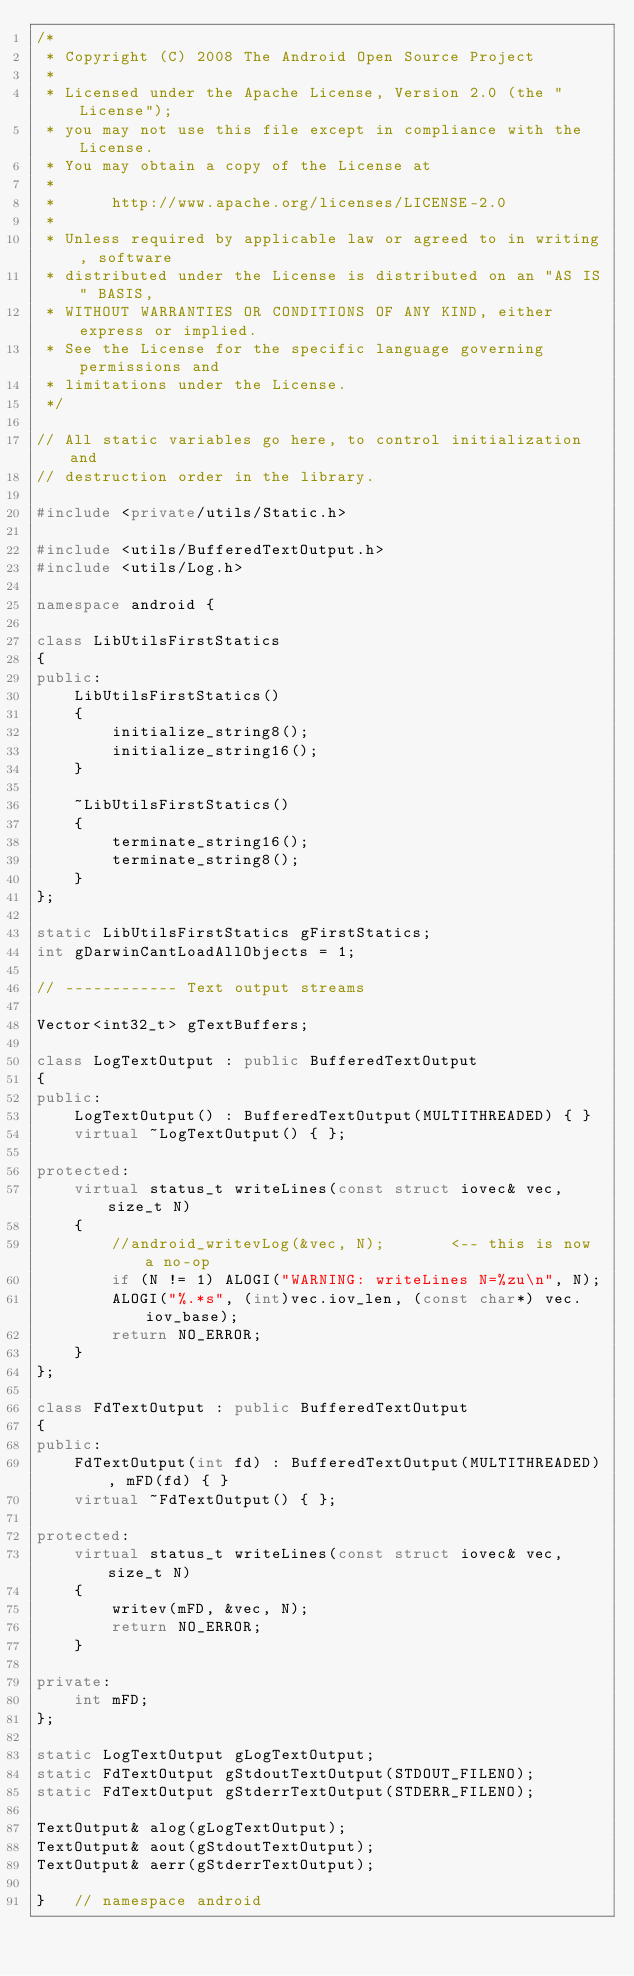Convert code to text. <code><loc_0><loc_0><loc_500><loc_500><_C++_>/*
 * Copyright (C) 2008 The Android Open Source Project
 *
 * Licensed under the Apache License, Version 2.0 (the "License");
 * you may not use this file except in compliance with the License.
 * You may obtain a copy of the License at
 *
 *      http://www.apache.org/licenses/LICENSE-2.0
 *
 * Unless required by applicable law or agreed to in writing, software
 * distributed under the License is distributed on an "AS IS" BASIS,
 * WITHOUT WARRANTIES OR CONDITIONS OF ANY KIND, either express or implied.
 * See the License for the specific language governing permissions and
 * limitations under the License.
 */

// All static variables go here, to control initialization and
// destruction order in the library.

#include <private/utils/Static.h>

#include <utils/BufferedTextOutput.h>
#include <utils/Log.h>

namespace android {

class LibUtilsFirstStatics
{
public:
    LibUtilsFirstStatics()
    {
        initialize_string8();
        initialize_string16();
    }
    
    ~LibUtilsFirstStatics()
    {
        terminate_string16();
        terminate_string8();
    }
};

static LibUtilsFirstStatics gFirstStatics;
int gDarwinCantLoadAllObjects = 1;

// ------------ Text output streams

Vector<int32_t> gTextBuffers;

class LogTextOutput : public BufferedTextOutput
{
public:
    LogTextOutput() : BufferedTextOutput(MULTITHREADED) { }
    virtual ~LogTextOutput() { };

protected:
    virtual status_t writeLines(const struct iovec& vec, size_t N)
    {
        //android_writevLog(&vec, N);       <-- this is now a no-op
        if (N != 1) ALOGI("WARNING: writeLines N=%zu\n", N);
        ALOGI("%.*s", (int)vec.iov_len, (const char*) vec.iov_base);
        return NO_ERROR;
    }
};

class FdTextOutput : public BufferedTextOutput
{
public:
    FdTextOutput(int fd) : BufferedTextOutput(MULTITHREADED), mFD(fd) { }
    virtual ~FdTextOutput() { };

protected:
    virtual status_t writeLines(const struct iovec& vec, size_t N)
    {
        writev(mFD, &vec, N);
        return NO_ERROR;
    }

private:
    int mFD;
};

static LogTextOutput gLogTextOutput;
static FdTextOutput gStdoutTextOutput(STDOUT_FILENO);
static FdTextOutput gStderrTextOutput(STDERR_FILENO);

TextOutput& alog(gLogTextOutput);
TextOutput& aout(gStdoutTextOutput);
TextOutput& aerr(gStderrTextOutput);

}   // namespace android
</code> 